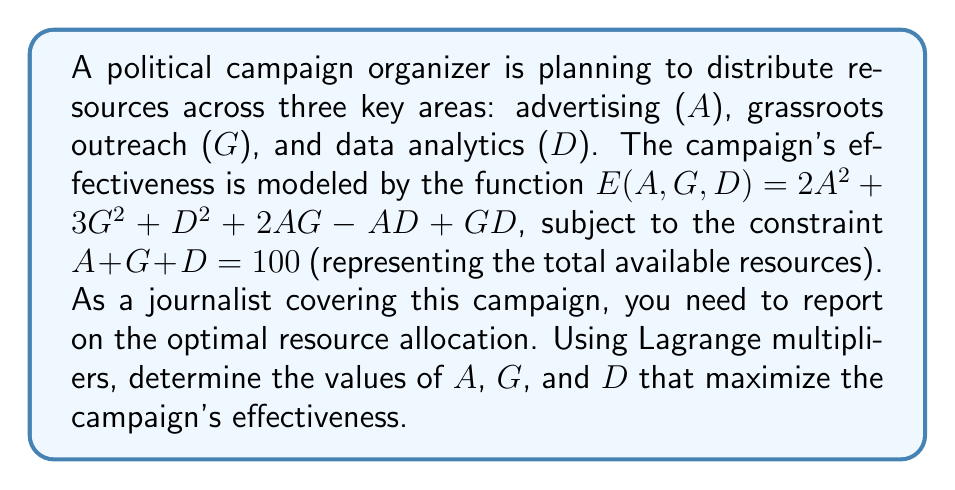Give your solution to this math problem. Let's solve this step-by-step using the method of Lagrange multipliers:

1) We define the Lagrangian function:
   $$L(A,G,D,\lambda) = 2A^2 + 3G^2 + D^2 + 2AG - AD + GD + \lambda(100 - A - G - D)$$

2) We set the partial derivatives equal to zero:
   $$\frac{\partial L}{\partial A} = 4A + 2G - D - \lambda = 0$$
   $$\frac{\partial L}{\partial G} = 6G + 2A + D - \lambda = 0$$
   $$\frac{\partial L}{\partial D} = 2D - A + G - \lambda = 0$$
   $$\frac{\partial L}{\partial \lambda} = 100 - A - G - D = 0$$

3) From the first equation:
   $$\lambda = 4A + 2G - D$$

4) Substituting this into the second and third equations:
   $$6G + 2A + D = 4A + 2G - D$$
   $$2D - A + G = 4A + 2G - D$$

5) Simplifying:
   $$4G = 2A - 2D$$
   $$3D = 5A + G$$

6) From the constraint equation:
   $$A + G + D = 100$$

7) We now have a system of three equations with three unknowns. Solving this system:
   $$A = 40$$
   $$G = 35$$
   $$D = 25$$

8) We can verify that these values satisfy the constraint:
   $$40 + 35 + 25 = 100$$

9) To confirm this is a maximum, we would need to check the second derivatives, but given the context of the problem, we can assume this is the case.
Answer: A = 40, G = 35, D = 25 